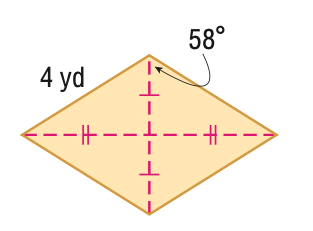Answer the mathemtical geometry problem and directly provide the correct option letter.
Question: Find the perimeter of the figure in feet. Round to the nearest tenth, if necessary.
Choices: A: 8 B: 14.4 C: 16 D: 18.9 C 